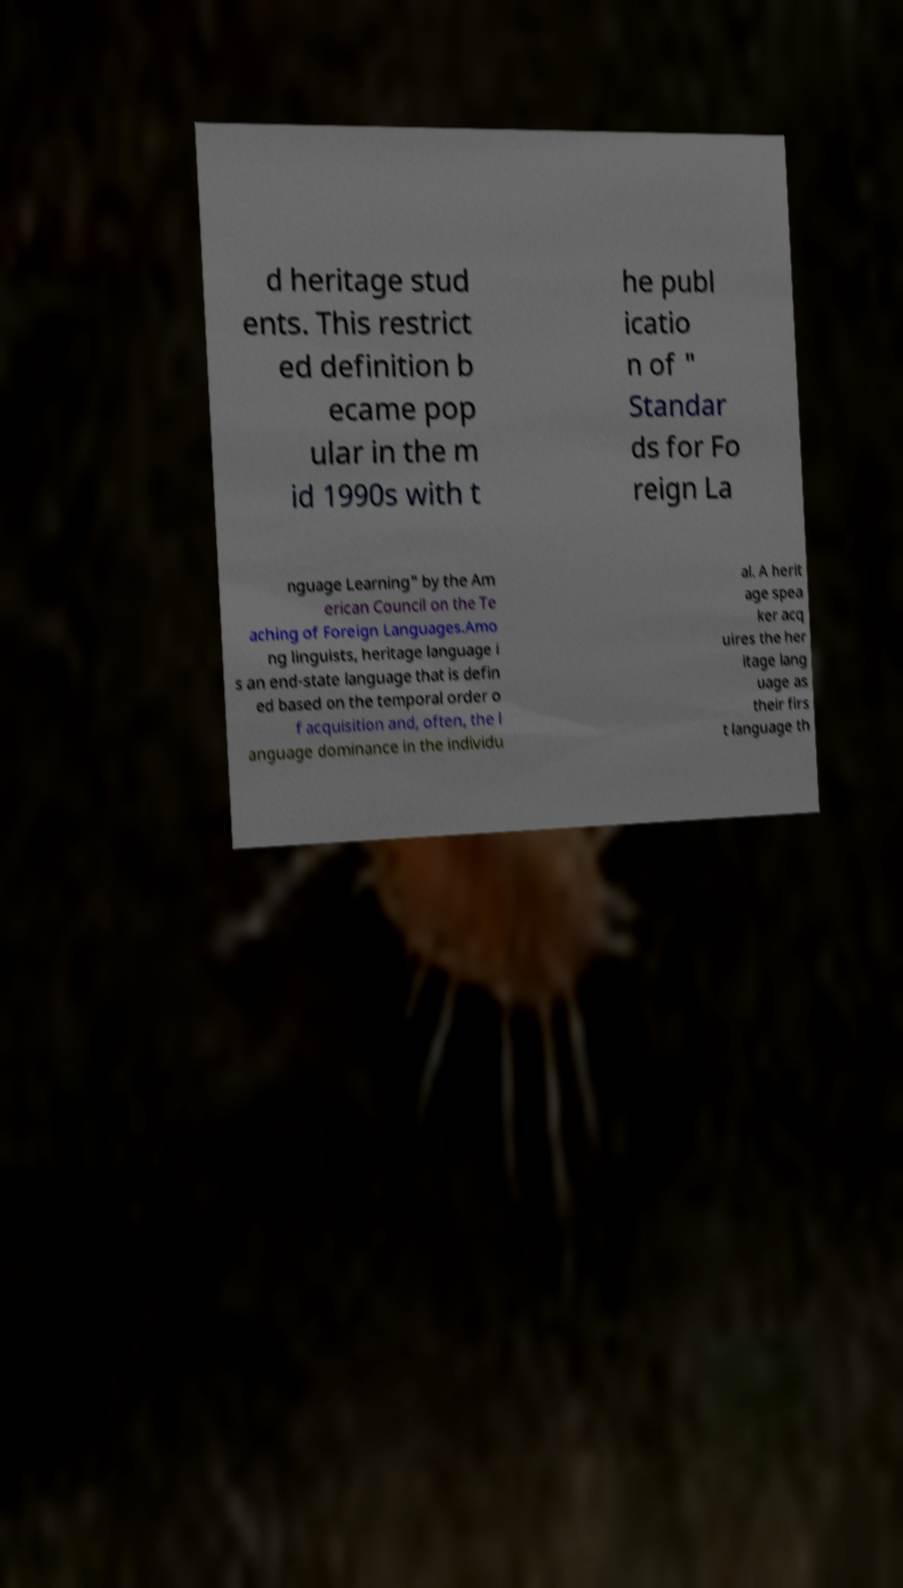Please identify and transcribe the text found in this image. d heritage stud ents. This restrict ed definition b ecame pop ular in the m id 1990s with t he publ icatio n of " Standar ds for Fo reign La nguage Learning" by the Am erican Council on the Te aching of Foreign Languages.Amo ng linguists, heritage language i s an end-state language that is defin ed based on the temporal order o f acquisition and, often, the l anguage dominance in the individu al. A herit age spea ker acq uires the her itage lang uage as their firs t language th 